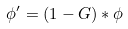Convert formula to latex. <formula><loc_0><loc_0><loc_500><loc_500>\phi ^ { \prime } = ( 1 - G ) * \phi</formula> 